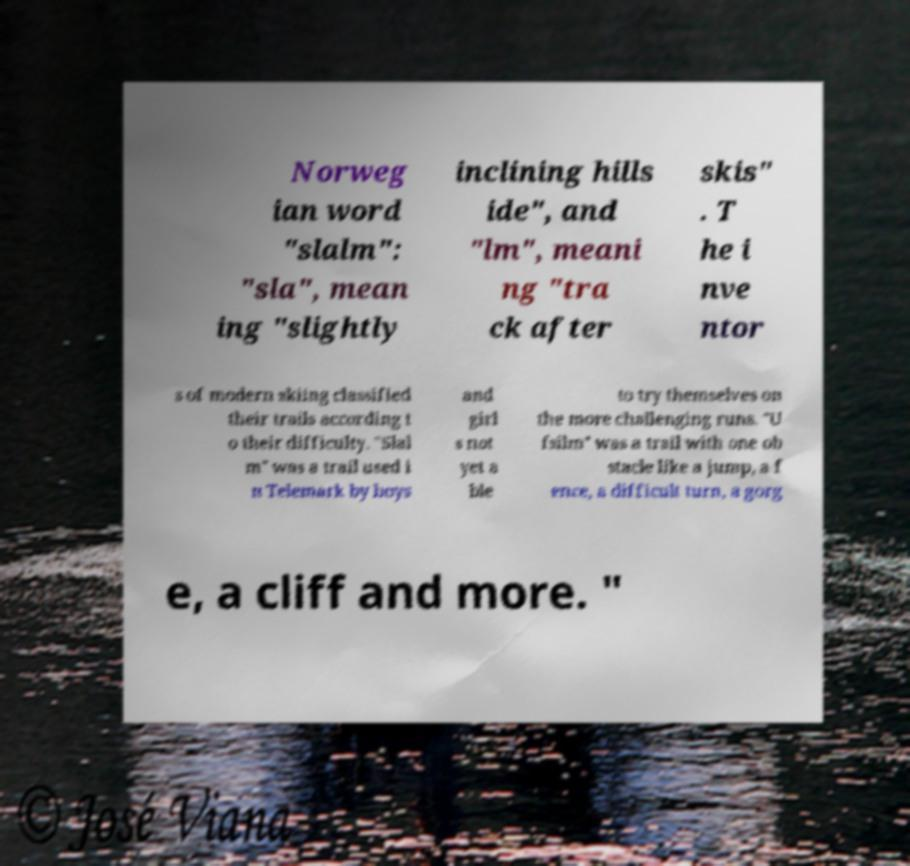Can you accurately transcribe the text from the provided image for me? Norweg ian word "slalm": "sla", mean ing "slightly inclining hills ide", and "lm", meani ng "tra ck after skis" . T he i nve ntor s of modern skiing classified their trails according t o their difficulty. "Slal m" was a trail used i n Telemark by boys and girl s not yet a ble to try themselves on the more challenging runs. "U fsilm" was a trail with one ob stacle like a jump, a f ence, a difficult turn, a gorg e, a cliff and more. " 